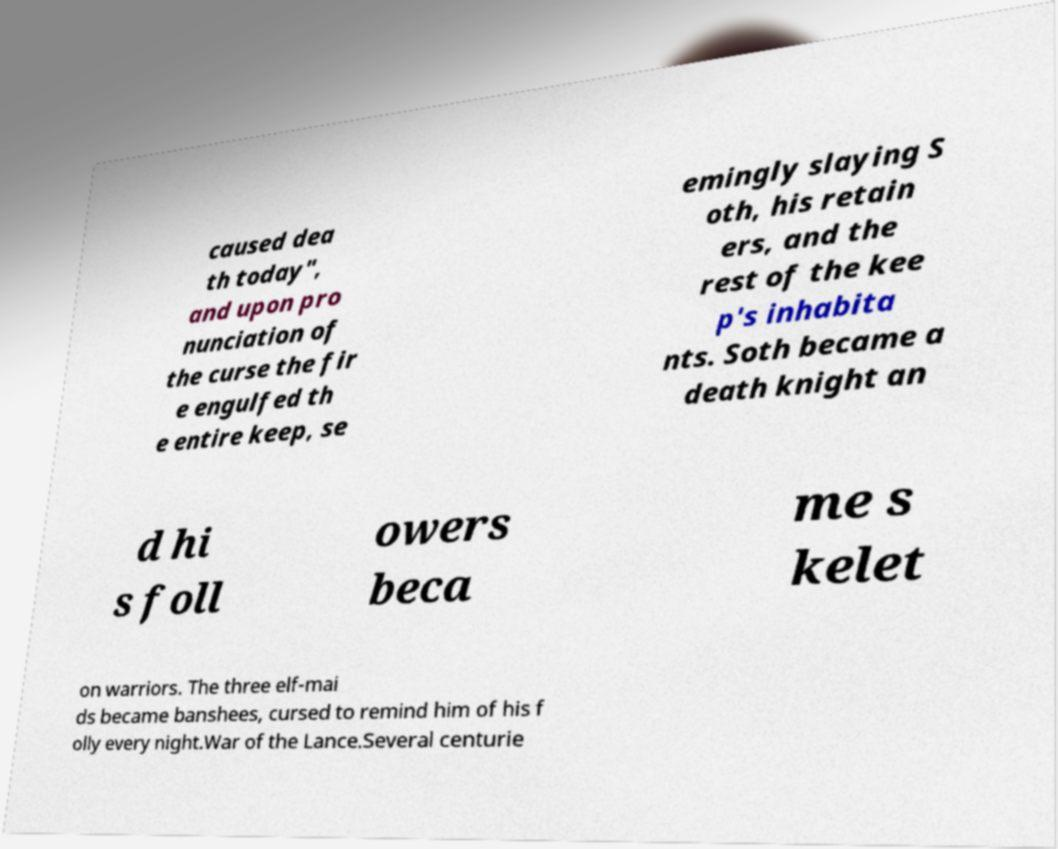Please identify and transcribe the text found in this image. caused dea th today", and upon pro nunciation of the curse the fir e engulfed th e entire keep, se emingly slaying S oth, his retain ers, and the rest of the kee p's inhabita nts. Soth became a death knight an d hi s foll owers beca me s kelet on warriors. The three elf-mai ds became banshees, cursed to remind him of his f olly every night.War of the Lance.Several centurie 